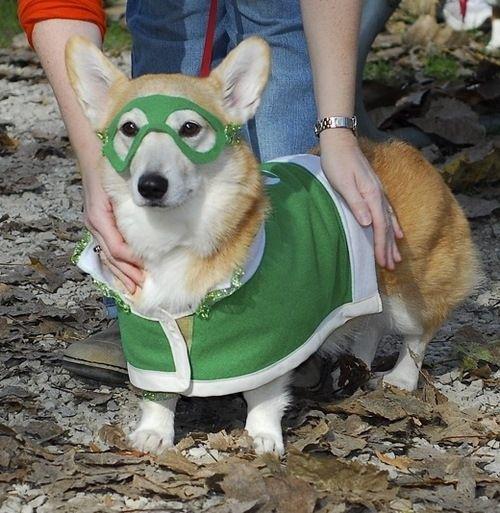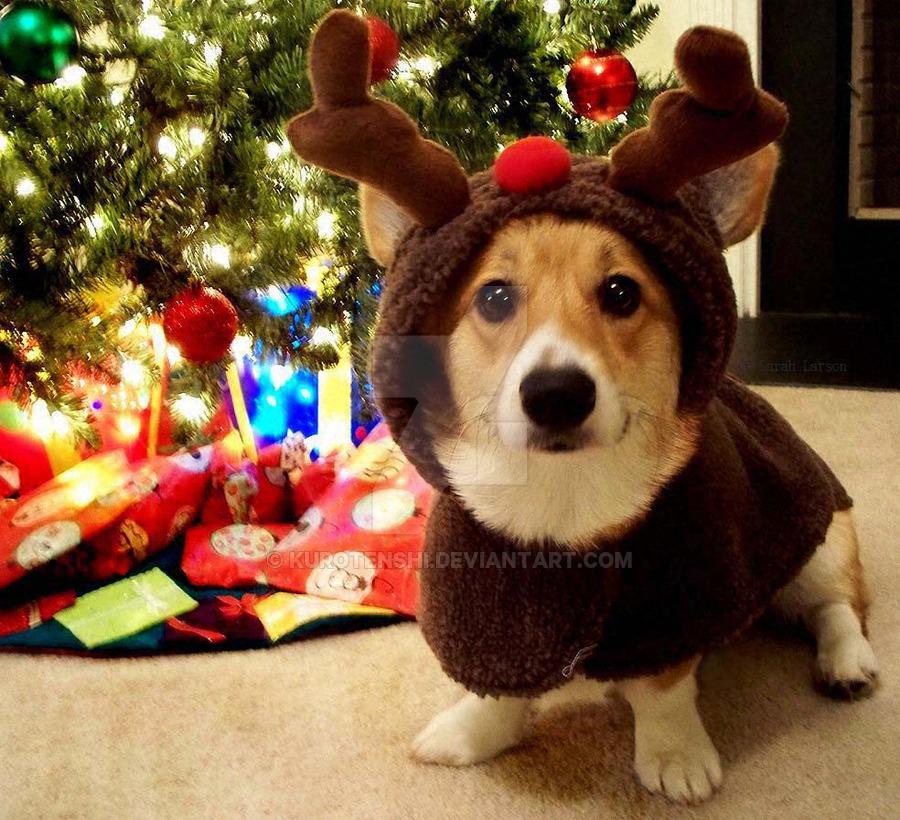The first image is the image on the left, the second image is the image on the right. Examine the images to the left and right. Is the description "There are two small dogs wearing costumes" accurate? Answer yes or no. Yes. The first image is the image on the left, the second image is the image on the right. Analyze the images presented: Is the assertion "Corgis are dressing in costumes" valid? Answer yes or no. Yes. 